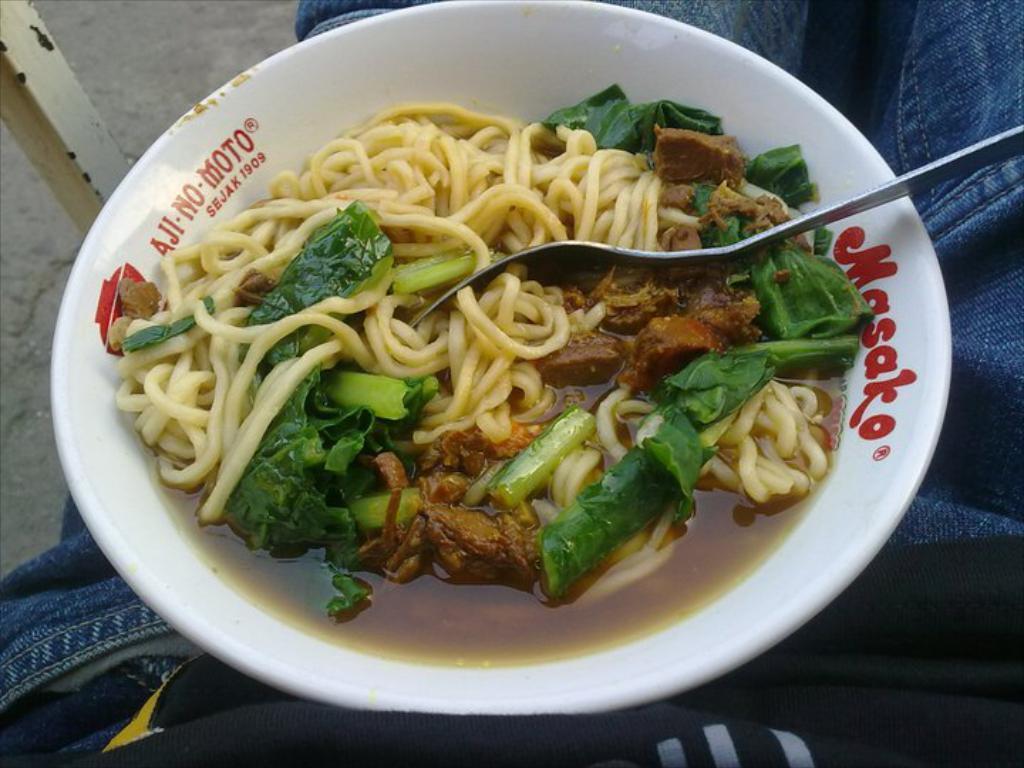How would you summarize this image in a sentence or two? In this picture there is an edible placed in a white bowl and there is a fork placed in it. 